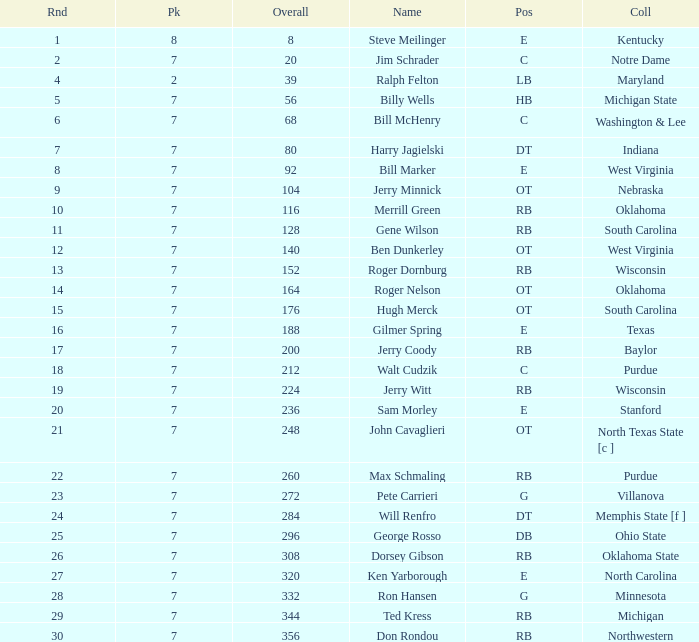What pick did George Rosso get drafted when the overall was less than 296? 0.0. 